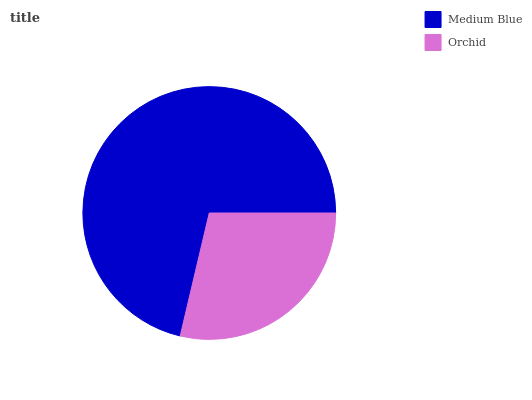Is Orchid the minimum?
Answer yes or no. Yes. Is Medium Blue the maximum?
Answer yes or no. Yes. Is Orchid the maximum?
Answer yes or no. No. Is Medium Blue greater than Orchid?
Answer yes or no. Yes. Is Orchid less than Medium Blue?
Answer yes or no. Yes. Is Orchid greater than Medium Blue?
Answer yes or no. No. Is Medium Blue less than Orchid?
Answer yes or no. No. Is Medium Blue the high median?
Answer yes or no. Yes. Is Orchid the low median?
Answer yes or no. Yes. Is Orchid the high median?
Answer yes or no. No. Is Medium Blue the low median?
Answer yes or no. No. 